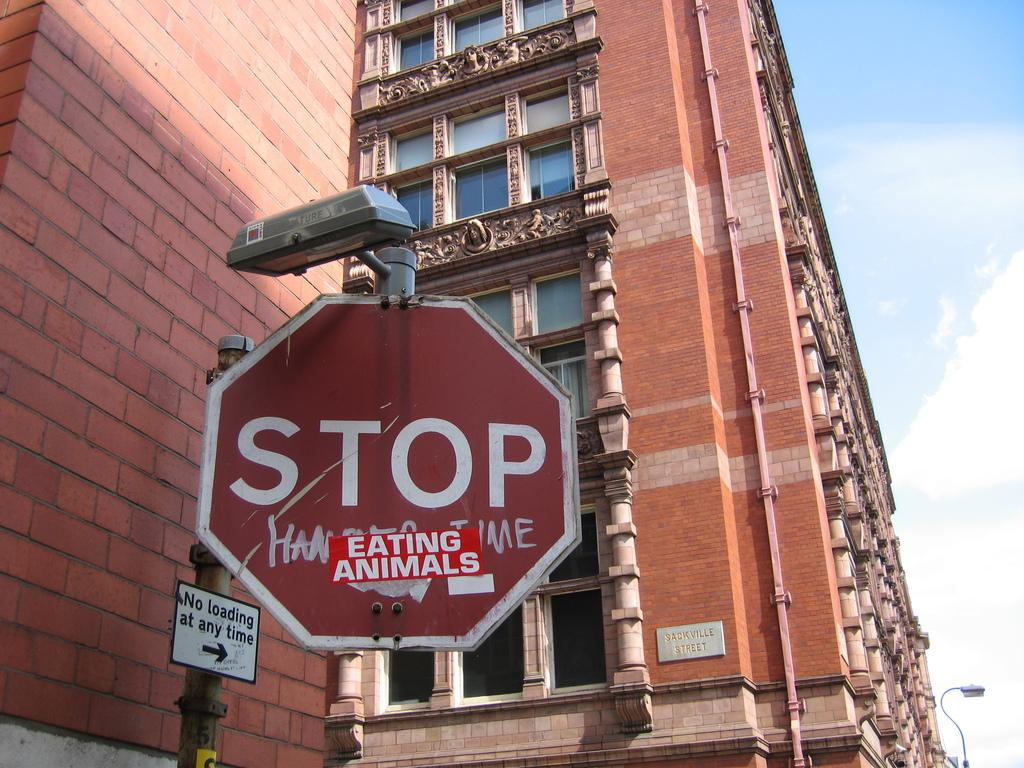<image>
Present a compact description of the photo's key features. a stop sign that has an eating animals tag under it 